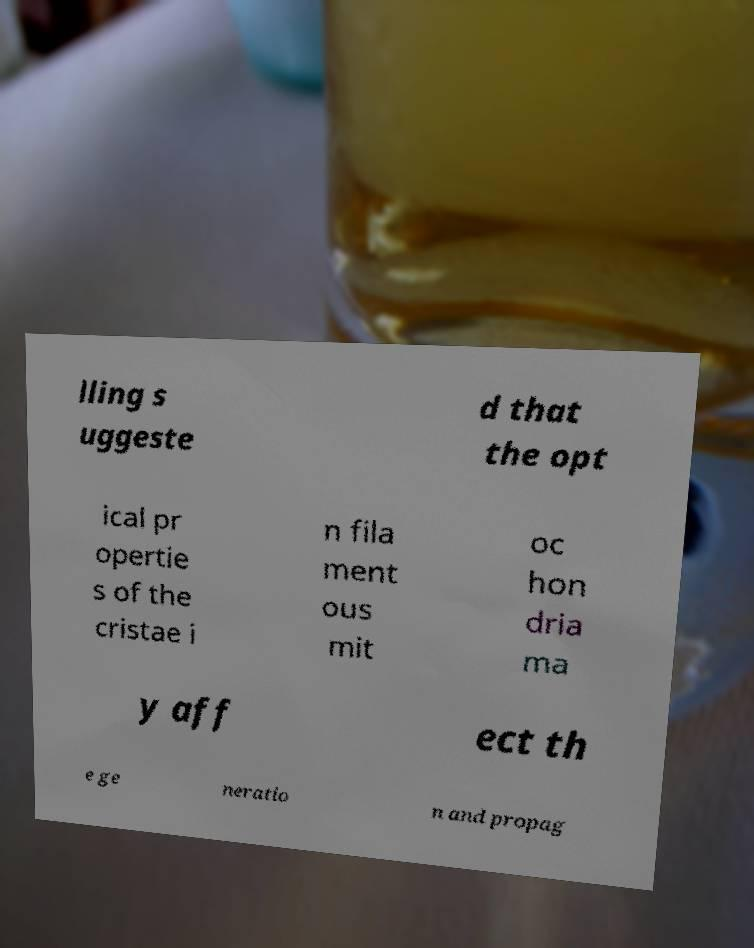I need the written content from this picture converted into text. Can you do that? lling s uggeste d that the opt ical pr opertie s of the cristae i n fila ment ous mit oc hon dria ma y aff ect th e ge neratio n and propag 